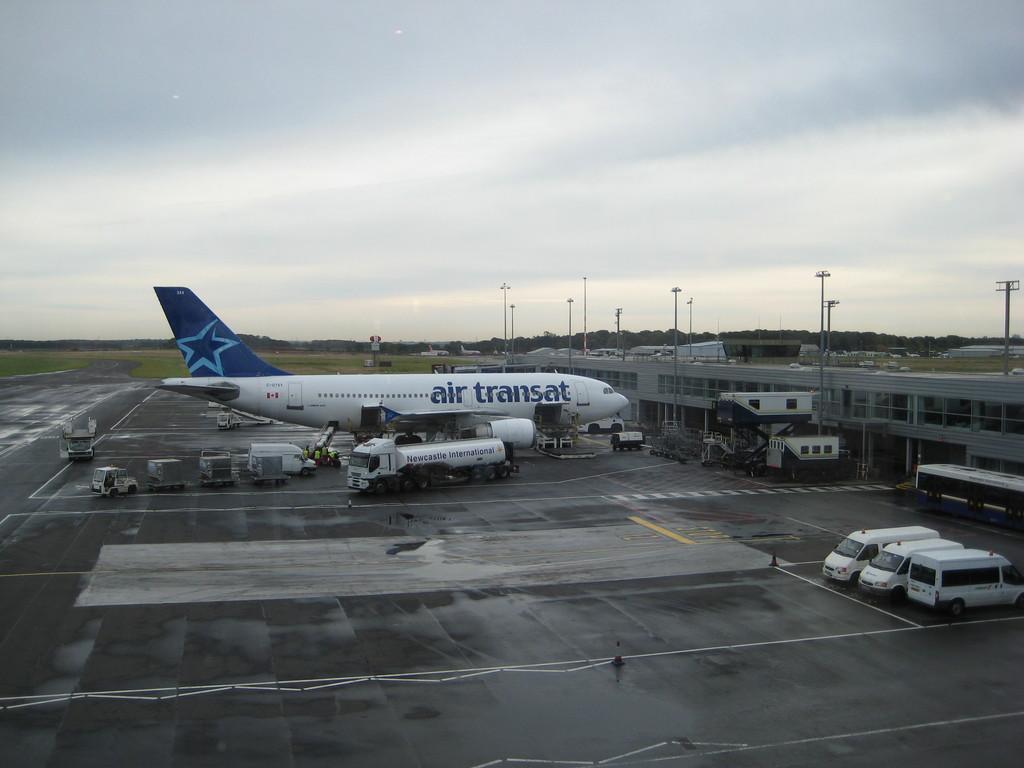What is written on the plane?
Provide a succinct answer. Air transat. This is a coffee  cup?
Offer a terse response. No. 